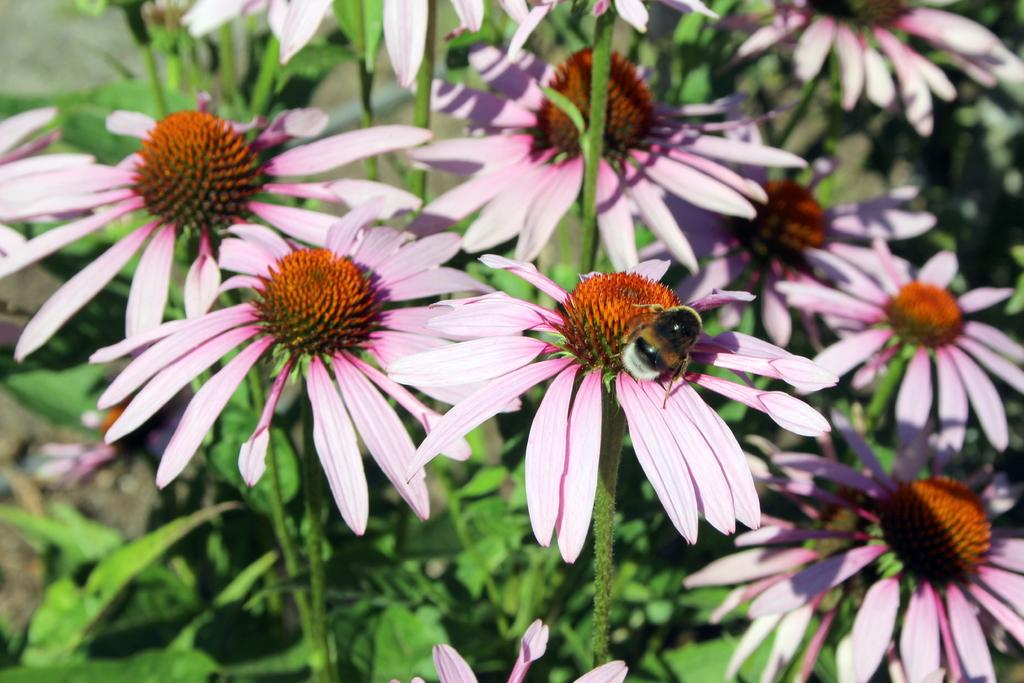What type of living organisms can be seen in the image? There are flowers and an insect in the image. Can you describe the insect in the image? Unfortunately, the facts provided do not give enough detail to describe the insect. However, we can confirm that there is an insect present. What type of ocean can be seen in the image? There is no ocean present in the image; it features flowers and an insect. How is the box used in the image? There is no box present in the image. 